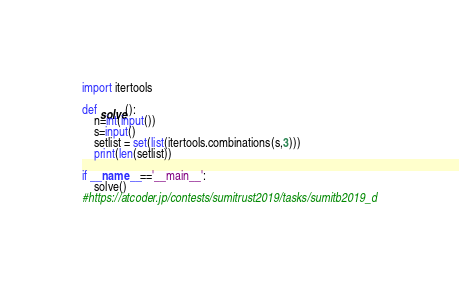Convert code to text. <code><loc_0><loc_0><loc_500><loc_500><_Python_>import itertools

def solve():
    n=int(input())
    s=input()
    setlist = set(list(itertools.combinations(s,3)))
    print(len(setlist))

if __name__=='__main__':
    solve()
#https://atcoder.jp/contests/sumitrust2019/tasks/sumitb2019_d</code> 